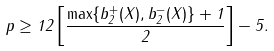<formula> <loc_0><loc_0><loc_500><loc_500>p \geq 1 2 \left [ \frac { \max \{ b _ { 2 } ^ { + } ( X ) , b _ { 2 } ^ { - } ( X ) \} + 1 } 2 \right ] - 5 .</formula> 